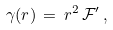Convert formula to latex. <formula><loc_0><loc_0><loc_500><loc_500>\gamma ( r ) \, = \, r ^ { 2 } \, \mathcal { F } ^ { \prime } \, ,</formula> 